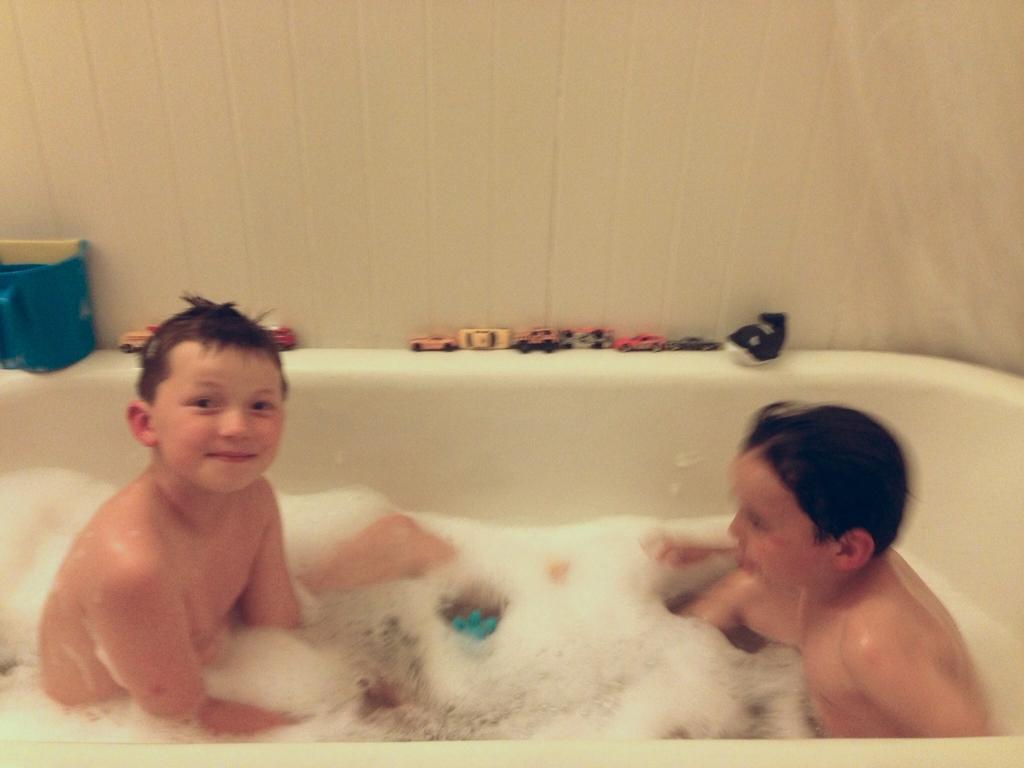In one or two sentences, can you explain what this image depicts? Here we can see two boys sitting in the bath tub and there is water in the tub and we can also foam and playing cards and a mug on the tub and this is a wall. 